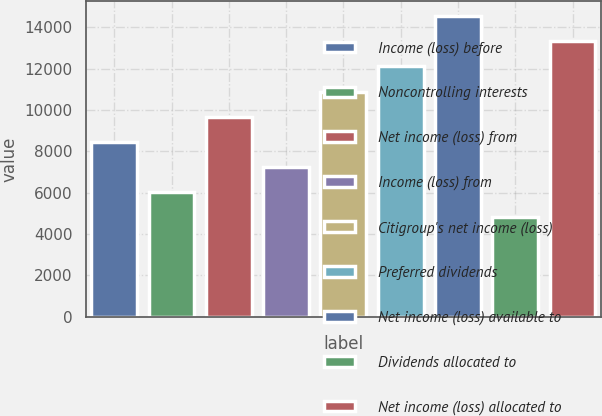<chart> <loc_0><loc_0><loc_500><loc_500><bar_chart><fcel>Income (loss) before<fcel>Noncontrolling interests<fcel>Net income (loss) from<fcel>Income (loss) from<fcel>Citigroup's net income (loss)<fcel>Preferred dividends<fcel>Net income (loss) available to<fcel>Dividends allocated to<fcel>Net income (loss) allocated to<nl><fcel>8469.34<fcel>6049.54<fcel>9679.24<fcel>7259.44<fcel>10889.1<fcel>12099<fcel>14518.8<fcel>4839.64<fcel>13308.9<nl></chart> 